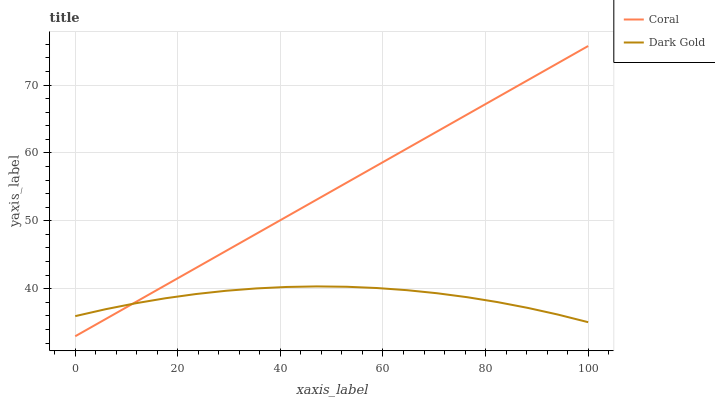Does Dark Gold have the minimum area under the curve?
Answer yes or no. Yes. Does Coral have the maximum area under the curve?
Answer yes or no. Yes. Does Dark Gold have the maximum area under the curve?
Answer yes or no. No. Is Coral the smoothest?
Answer yes or no. Yes. Is Dark Gold the roughest?
Answer yes or no. Yes. Is Dark Gold the smoothest?
Answer yes or no. No. Does Dark Gold have the lowest value?
Answer yes or no. No. Does Coral have the highest value?
Answer yes or no. Yes. Does Dark Gold have the highest value?
Answer yes or no. No. Does Coral intersect Dark Gold?
Answer yes or no. Yes. Is Coral less than Dark Gold?
Answer yes or no. No. Is Coral greater than Dark Gold?
Answer yes or no. No. 